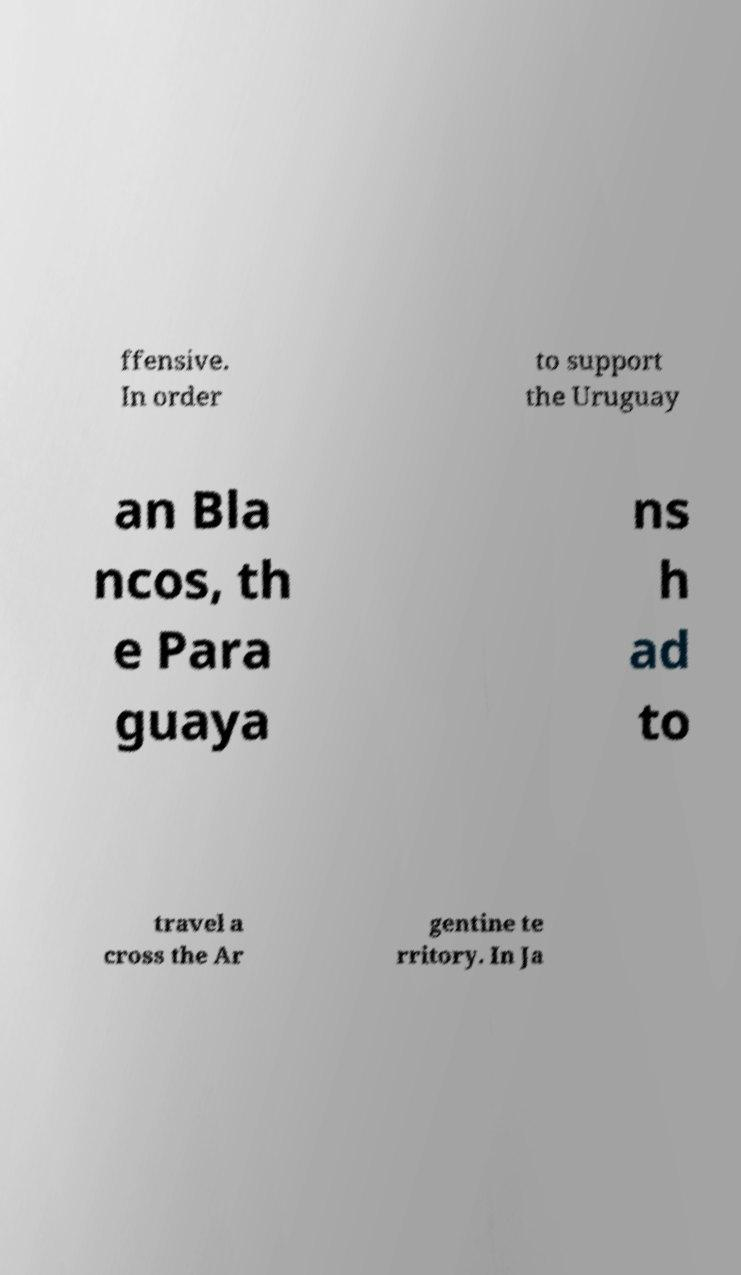Could you assist in decoding the text presented in this image and type it out clearly? ffensive. In order to support the Uruguay an Bla ncos, th e Para guaya ns h ad to travel a cross the Ar gentine te rritory. In Ja 